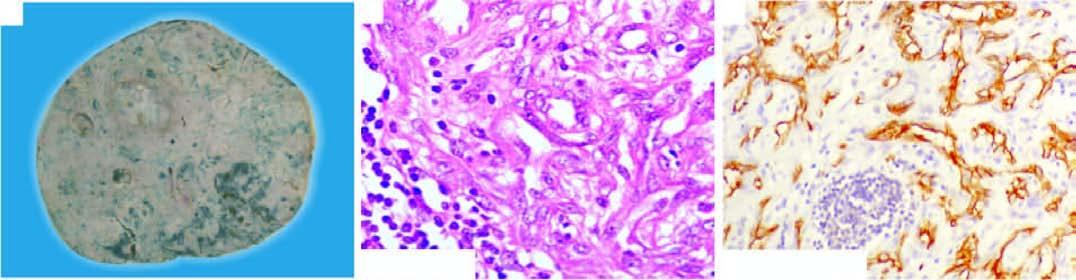do these tumour cells show positive staining for endothelial marker, cd34?
Answer the question using a single word or phrase. Yes 